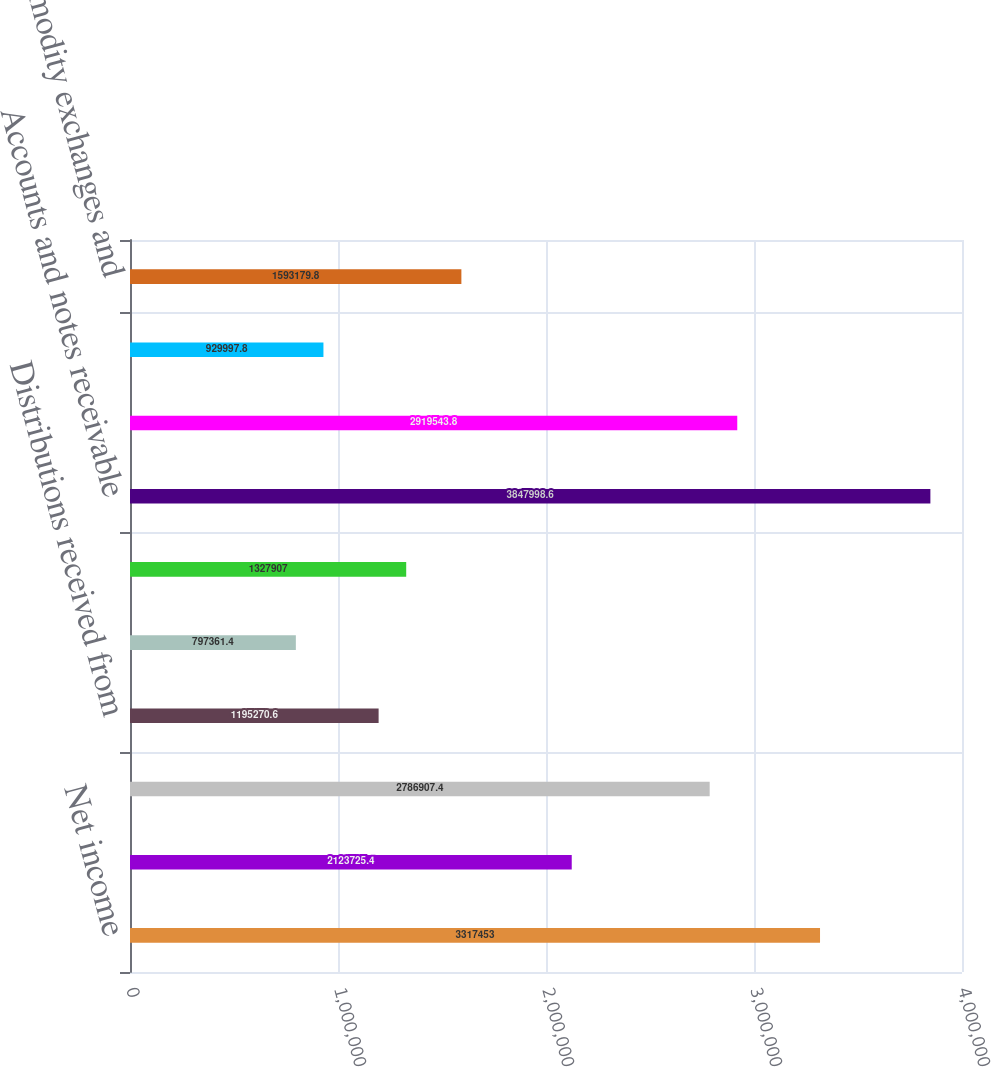<chart> <loc_0><loc_0><loc_500><loc_500><bar_chart><fcel>Net income<fcel>Depreciation and amortization<fcel>Gain on sale of assets<fcel>Distributions received from<fcel>Income from equity investments<fcel>Allowance for doubtful<fcel>Accounts and notes receivable<fcel>Inventories<fcel>Unrecovered purchased gas<fcel>Commodity exchanges and<nl><fcel>3.31745e+06<fcel>2.12373e+06<fcel>2.78691e+06<fcel>1.19527e+06<fcel>797361<fcel>1.32791e+06<fcel>3.848e+06<fcel>2.91954e+06<fcel>929998<fcel>1.59318e+06<nl></chart> 